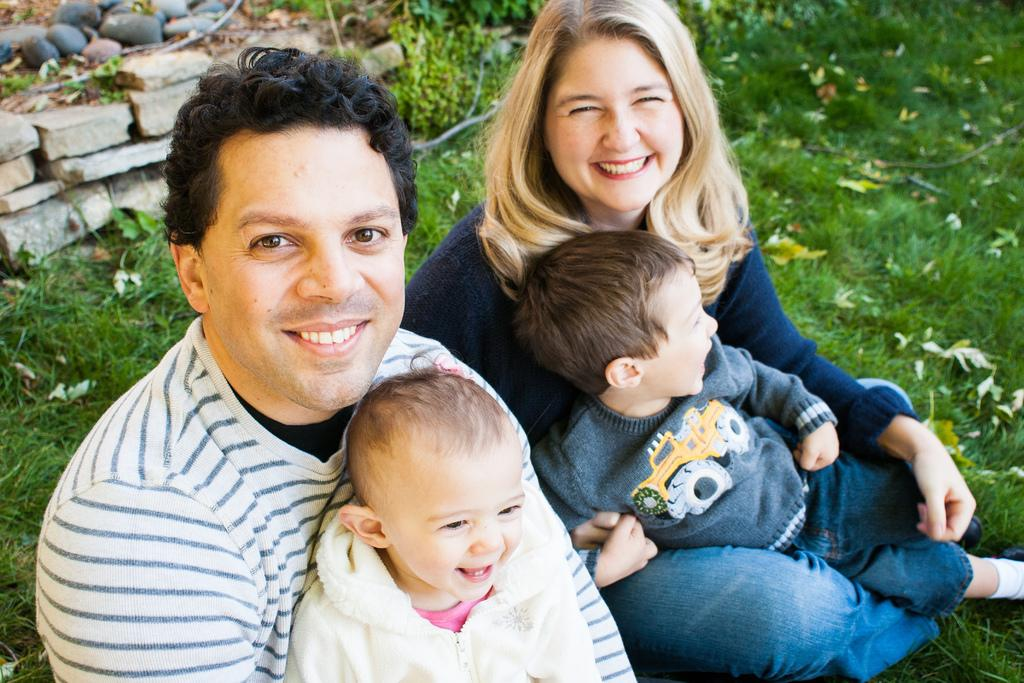How many kids are in the image? There are two kids in the image. What are the kids doing in the image? The kids are sitting on a man and a woman. What type of surface can be seen beneath the kids? There is grass visible in the image. What other natural elements are present in the image? Leaves and stones are present in the image. What type of skin condition can be seen on the kids in the image? There is no indication of any skin condition on the kids in the image. What historical event is depicted in the image? There is no historical event depicted in the image; it shows two kids sitting on a man and a woman in a natural setting. 